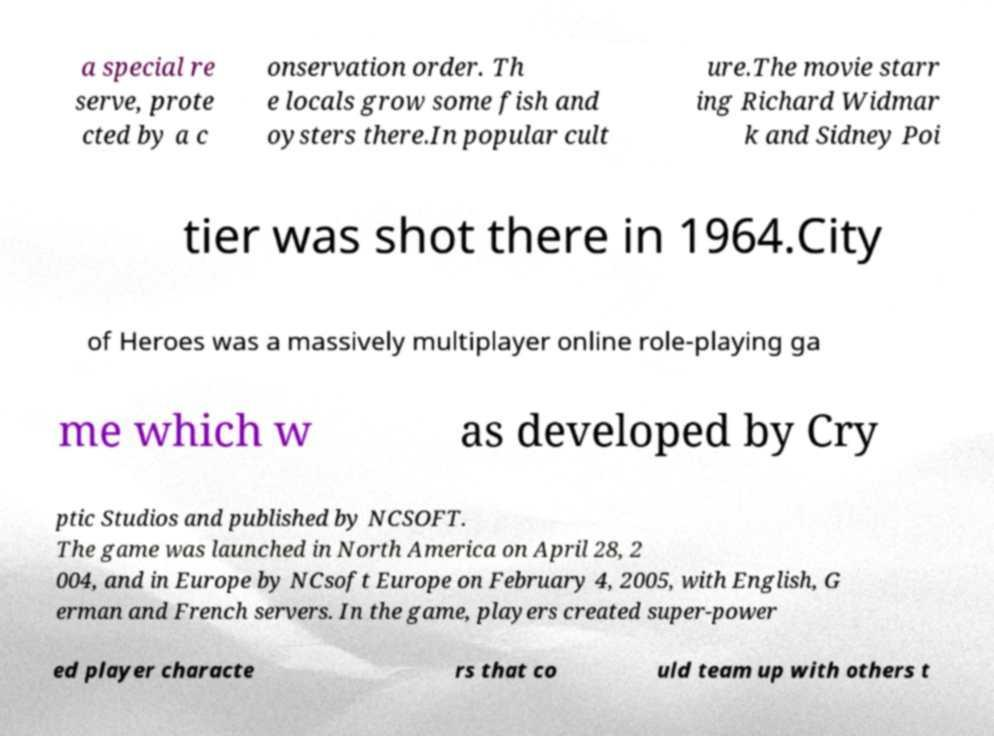Please identify and transcribe the text found in this image. a special re serve, prote cted by a c onservation order. Th e locals grow some fish and oysters there.In popular cult ure.The movie starr ing Richard Widmar k and Sidney Poi tier was shot there in 1964.City of Heroes was a massively multiplayer online role-playing ga me which w as developed by Cry ptic Studios and published by NCSOFT. The game was launched in North America on April 28, 2 004, and in Europe by NCsoft Europe on February 4, 2005, with English, G erman and French servers. In the game, players created super-power ed player characte rs that co uld team up with others t 